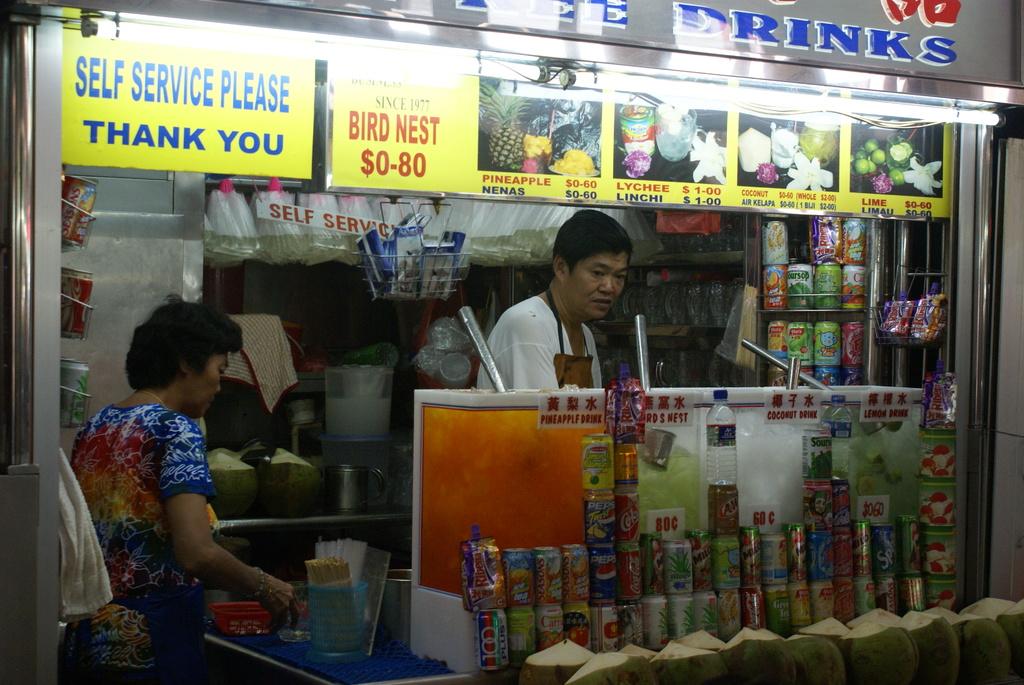How much is a bird nest?
Keep it short and to the point. $0-80. What does the sign with the blue text?
Ensure brevity in your answer.  Self service please thank you. 